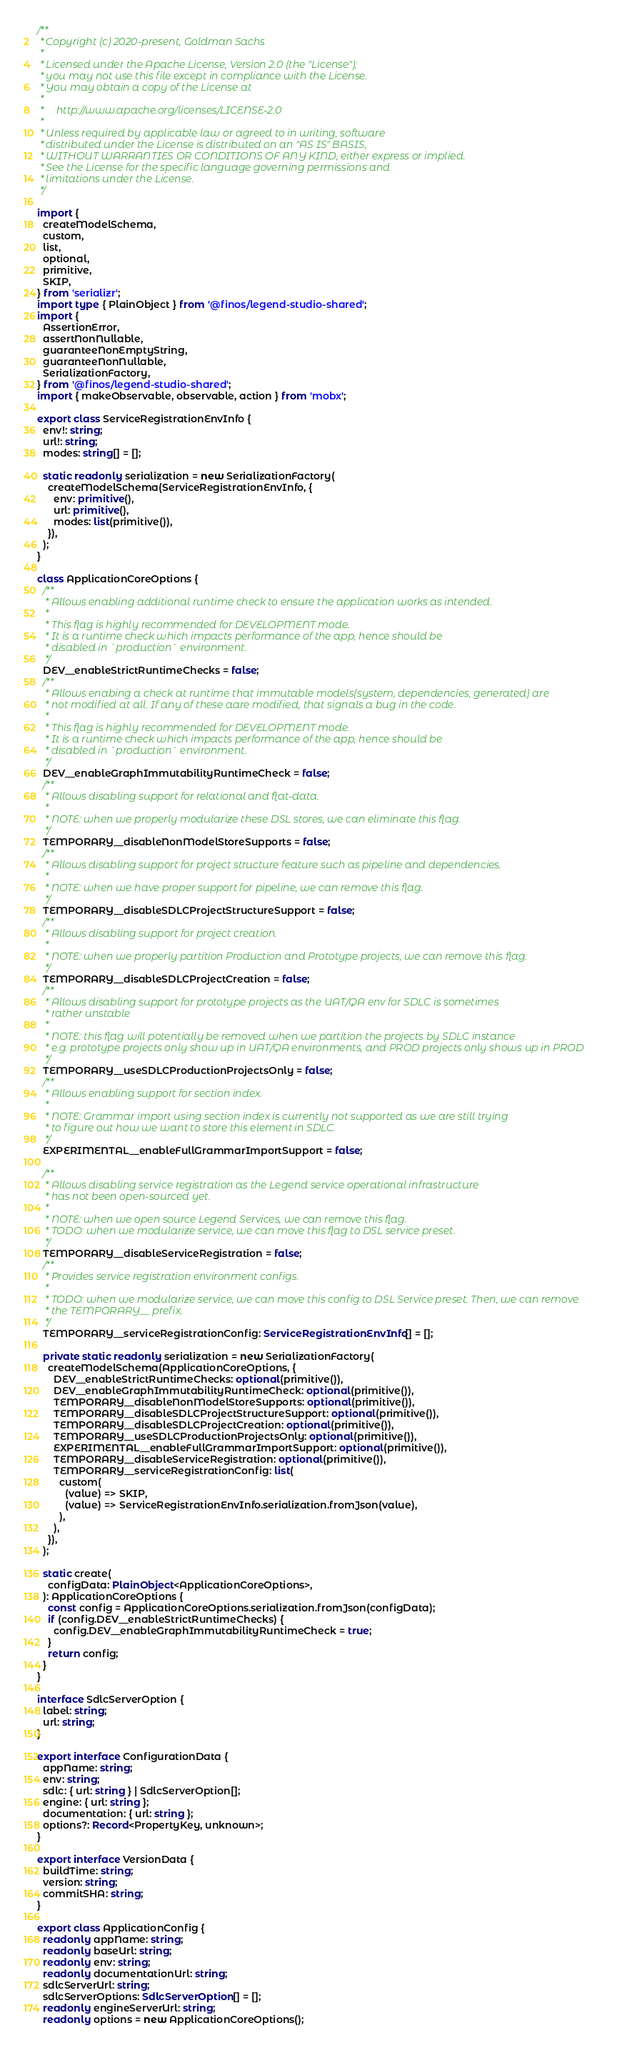Convert code to text. <code><loc_0><loc_0><loc_500><loc_500><_TypeScript_>/**
 * Copyright (c) 2020-present, Goldman Sachs
 *
 * Licensed under the Apache License, Version 2.0 (the "License");
 * you may not use this file except in compliance with the License.
 * You may obtain a copy of the License at
 *
 *     http://www.apache.org/licenses/LICENSE-2.0
 *
 * Unless required by applicable law or agreed to in writing, software
 * distributed under the License is distributed on an "AS IS" BASIS,
 * WITHOUT WARRANTIES OR CONDITIONS OF ANY KIND, either express or implied.
 * See the License for the specific language governing permissions and
 * limitations under the License.
 */

import {
  createModelSchema,
  custom,
  list,
  optional,
  primitive,
  SKIP,
} from 'serializr';
import type { PlainObject } from '@finos/legend-studio-shared';
import {
  AssertionError,
  assertNonNullable,
  guaranteeNonEmptyString,
  guaranteeNonNullable,
  SerializationFactory,
} from '@finos/legend-studio-shared';
import { makeObservable, observable, action } from 'mobx';

export class ServiceRegistrationEnvInfo {
  env!: string;
  url!: string;
  modes: string[] = [];

  static readonly serialization = new SerializationFactory(
    createModelSchema(ServiceRegistrationEnvInfo, {
      env: primitive(),
      url: primitive(),
      modes: list(primitive()),
    }),
  );
}

class ApplicationCoreOptions {
  /**
   * Allows enabling additional runtime check to ensure the application works as intended.
   *
   * This flag is highly recommended for DEVELOPMENT mode.
   * It is a runtime check which impacts performance of the app, hence should be
   * disabled in `production` environment.
   */
  DEV__enableStrictRuntimeChecks = false;
  /**
   * Allows enabing a check at runtime that immutable models(system, dependencies, generated) are
   * not modified at all. If any of these aare modified, that signals a bug in the code.
   *
   * This flag is highly recommended for DEVELOPMENT mode.
   * It is a runtime check which impacts performance of the app, hence should be
   * disabled in `production` environment.
   */
  DEV__enableGraphImmutabilityRuntimeCheck = false;
  /**
   * Allows disabling support for relational and flat-data.
   *
   * NOTE: when we properly modularize these DSL stores, we can eliminate this flag.
   */
  TEMPORARY__disableNonModelStoreSupports = false;
  /**
   * Allows disabling support for project structure feature such as pipeline and dependencies.
   *
   * NOTE: when we have proper support for pipeline, we can remove this flag.
   */
  TEMPORARY__disableSDLCProjectStructureSupport = false;
  /**
   * Allows disabling support for project creation.
   *
   * NOTE: when we properly partition Production and Prototype projects, we can remove this flag.
   */
  TEMPORARY__disableSDLCProjectCreation = false;
  /**
   * Allows disabling support for prototype projects as the UAT/QA env for SDLC is sometimes
   * rather unstable
   *
   * NOTE: this flag will potentially be removed when we partition the projects by SDLC instance
   * e.g. prototype projects only show up in UAT/QA environments, and PROD projects only shows up in PROD
   */
  TEMPORARY__useSDLCProductionProjectsOnly = false;
  /**
   * Allows enabling support for section index.
   *
   * NOTE: Grammar import using section index is currently not supported as we are still trying
   * to figure out how we want to store this element in SDLC.
   */
  EXPERIMENTAL__enableFullGrammarImportSupport = false;

  /**
   * Allows disabling service registration as the Legend service operational infrastructure
   * has not been open-sourced yet.
   *
   * NOTE: when we open source Legend Services, we can remove this flag.
   * TODO: when we modularize service, we can move this flag to DSL service preset.
   */
  TEMPORARY__disableServiceRegistration = false;
  /**
   * Provides service registration environment configs.
   *
   * TODO: when we modularize service, we can move this config to DSL Service preset. Then, we can remove
   * the TEMPORARY__ prefix.
   */
  TEMPORARY__serviceRegistrationConfig: ServiceRegistrationEnvInfo[] = [];

  private static readonly serialization = new SerializationFactory(
    createModelSchema(ApplicationCoreOptions, {
      DEV__enableStrictRuntimeChecks: optional(primitive()),
      DEV__enableGraphImmutabilityRuntimeCheck: optional(primitive()),
      TEMPORARY__disableNonModelStoreSupports: optional(primitive()),
      TEMPORARY__disableSDLCProjectStructureSupport: optional(primitive()),
      TEMPORARY__disableSDLCProjectCreation: optional(primitive()),
      TEMPORARY__useSDLCProductionProjectsOnly: optional(primitive()),
      EXPERIMENTAL__enableFullGrammarImportSupport: optional(primitive()),
      TEMPORARY__disableServiceRegistration: optional(primitive()),
      TEMPORARY__serviceRegistrationConfig: list(
        custom(
          (value) => SKIP,
          (value) => ServiceRegistrationEnvInfo.serialization.fromJson(value),
        ),
      ),
    }),
  );

  static create(
    configData: PlainObject<ApplicationCoreOptions>,
  ): ApplicationCoreOptions {
    const config = ApplicationCoreOptions.serialization.fromJson(configData);
    if (config.DEV__enableStrictRuntimeChecks) {
      config.DEV__enableGraphImmutabilityRuntimeCheck = true;
    }
    return config;
  }
}

interface SdlcServerOption {
  label: string;
  url: string;
}

export interface ConfigurationData {
  appName: string;
  env: string;
  sdlc: { url: string } | SdlcServerOption[];
  engine: { url: string };
  documentation: { url: string };
  options?: Record<PropertyKey, unknown>;
}

export interface VersionData {
  buildTime: string;
  version: string;
  commitSHA: string;
}

export class ApplicationConfig {
  readonly appName: string;
  readonly baseUrl: string;
  readonly env: string;
  readonly documentationUrl: string;
  sdlcServerUrl: string;
  sdlcServerOptions: SdlcServerOption[] = [];
  readonly engineServerUrl: string;
  readonly options = new ApplicationCoreOptions();
</code> 